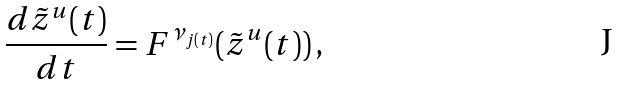Convert formula to latex. <formula><loc_0><loc_0><loc_500><loc_500>\frac { d \tilde { z } ^ { u } ( t ) } { d t } = F ^ { \nu _ { j ( t ) } } ( \tilde { z } ^ { u } ( t ) ) \, ,</formula> 